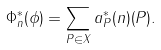Convert formula to latex. <formula><loc_0><loc_0><loc_500><loc_500>\Phi ^ { \ast } _ { n } ( \phi ) = \sum _ { P \in X } a _ { P } ^ { \ast } ( n ) ( P ) .</formula> 